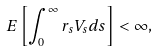Convert formula to latex. <formula><loc_0><loc_0><loc_500><loc_500>E \left [ \int _ { 0 } ^ { \infty } r _ { s } V _ { s } d s \right ] < \infty ,</formula> 